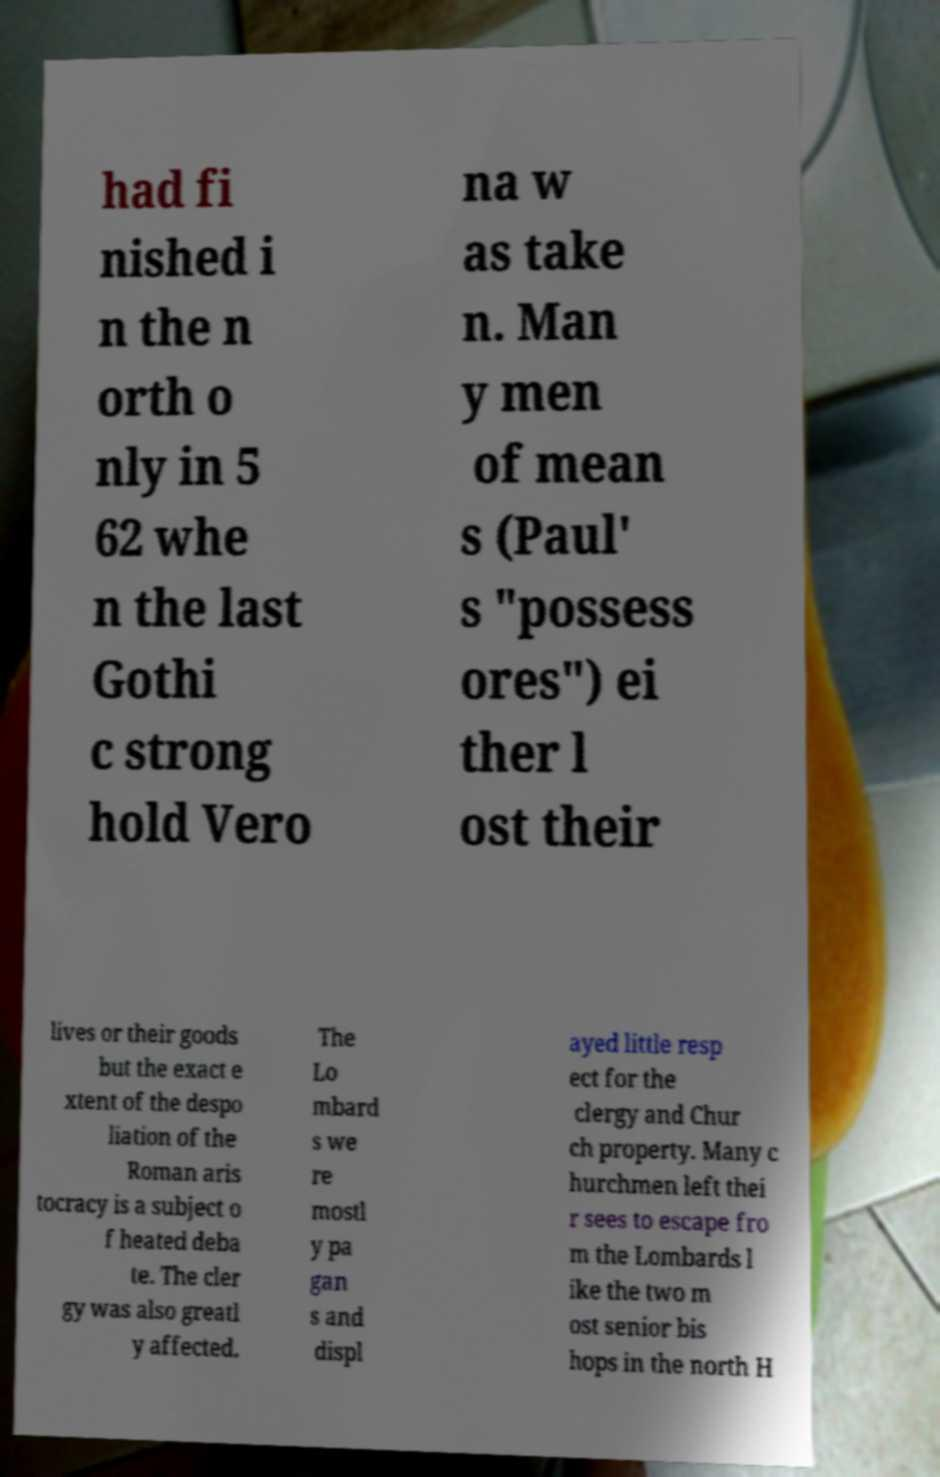There's text embedded in this image that I need extracted. Can you transcribe it verbatim? had fi nished i n the n orth o nly in 5 62 whe n the last Gothi c strong hold Vero na w as take n. Man y men of mean s (Paul' s "possess ores") ei ther l ost their lives or their goods but the exact e xtent of the despo liation of the Roman aris tocracy is a subject o f heated deba te. The cler gy was also greatl y affected. The Lo mbard s we re mostl y pa gan s and displ ayed little resp ect for the clergy and Chur ch property. Many c hurchmen left thei r sees to escape fro m the Lombards l ike the two m ost senior bis hops in the north H 